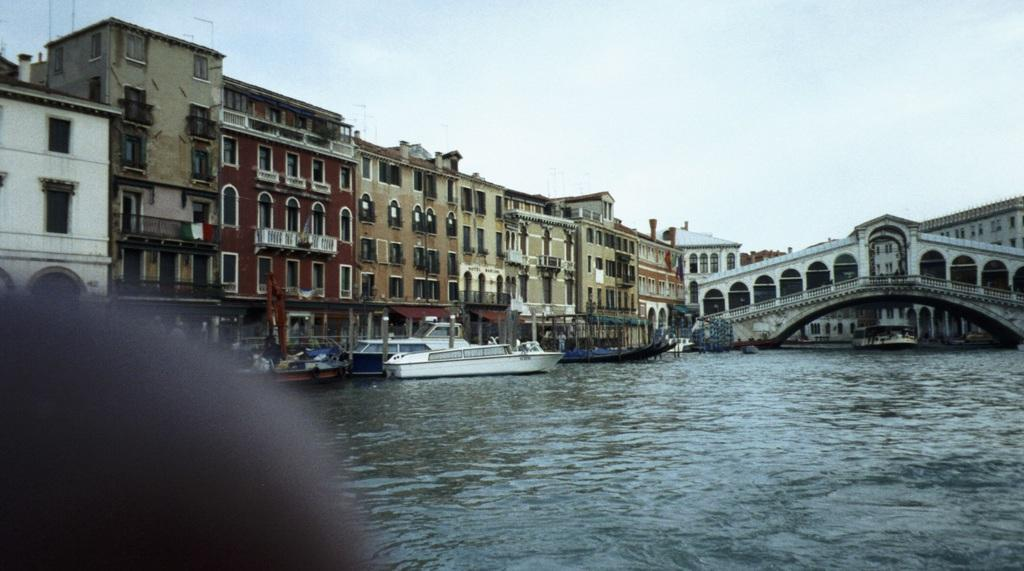What type of structures can be seen in the image? There are many buildings in the image. What connects the two sides of the water in the image? There is a bridge in the image. What type of vehicles are on the water in the image? There are boats on the water in the image. What is visible at the top of the image? The sky is visible at the top of the image. How many heads can be seen on the bridge in the image? There are no heads visible on the bridge in the image. What is the wealth status of the boats in the image? The wealth status of the boats cannot be determined from the image. 